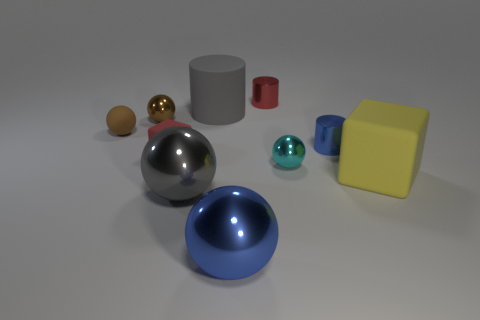Subtract all gray cubes. How many brown balls are left? 2 Subtract all matte balls. How many balls are left? 4 Subtract 3 balls. How many balls are left? 2 Subtract all brown spheres. How many spheres are left? 3 Subtract all gray balls. Subtract all green blocks. How many balls are left? 4 Subtract all cylinders. How many objects are left? 7 Add 1 small green matte cylinders. How many small green matte cylinders exist? 1 Subtract 0 green cubes. How many objects are left? 10 Subtract all big cyan rubber objects. Subtract all blue balls. How many objects are left? 9 Add 8 brown rubber balls. How many brown rubber balls are left? 9 